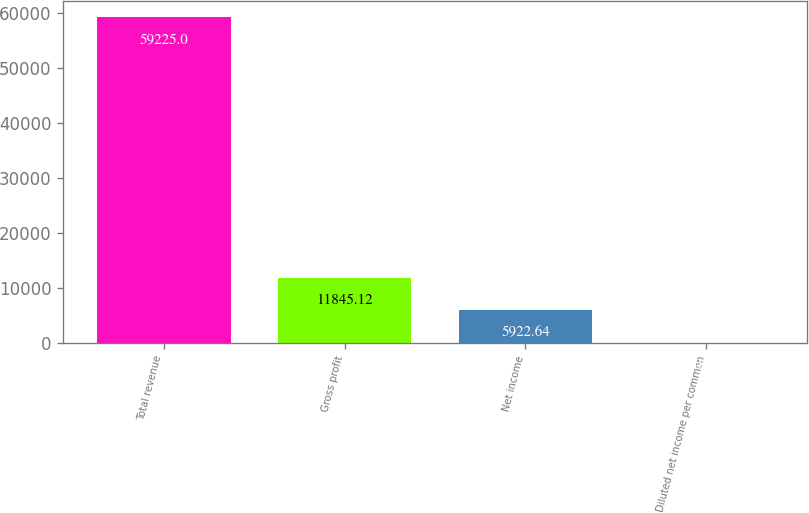<chart> <loc_0><loc_0><loc_500><loc_500><bar_chart><fcel>Total revenue<fcel>Gross profit<fcel>Net income<fcel>Diluted net income per common<nl><fcel>59225<fcel>11845.1<fcel>5922.64<fcel>0.15<nl></chart> 